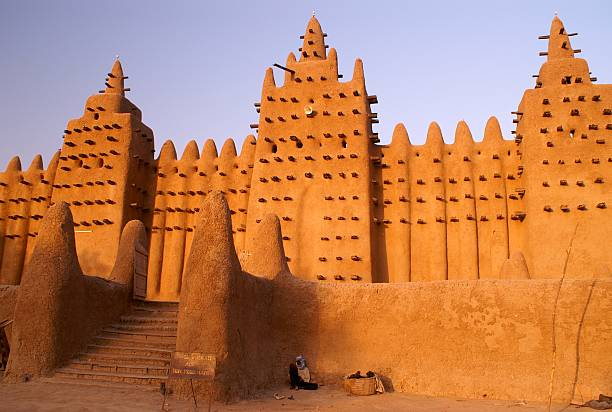What kind of scenes might unfold in front of this mosque at different times of the day? At dawn, the scene in front of the Great Mosque of Djenné is serene, with the first light silhouetting the majestic structure against the soft blue sky. The call to prayer reverberates through the air as people begin to gather, their shadows stretching across the earth. By mid-morning, the square bustles with the activity of the local market. Stalls laden with fruits, vegetables, textiles, and wares create a tapestry of color, sound, and movement. Merchants haggle with buyers, and children dart between the stalls with playful energy. As the sun climbs high, the mosque stands stoically under the intense light, casting deep shadows that offer brief respite from the heat. In the late afternoon, the square starts to calm; vendors pack up their goods, and the warm, golden light returns, bathing the mosque in a nostalgic glow. Evening brings another prayer gathering, with soft conversations filling the cooling air, and twinkling stars beginning to emerge above. Each period of the day enriches the mosque with a unique atmosphere, reflecting the rhythm of life in Djenné. 